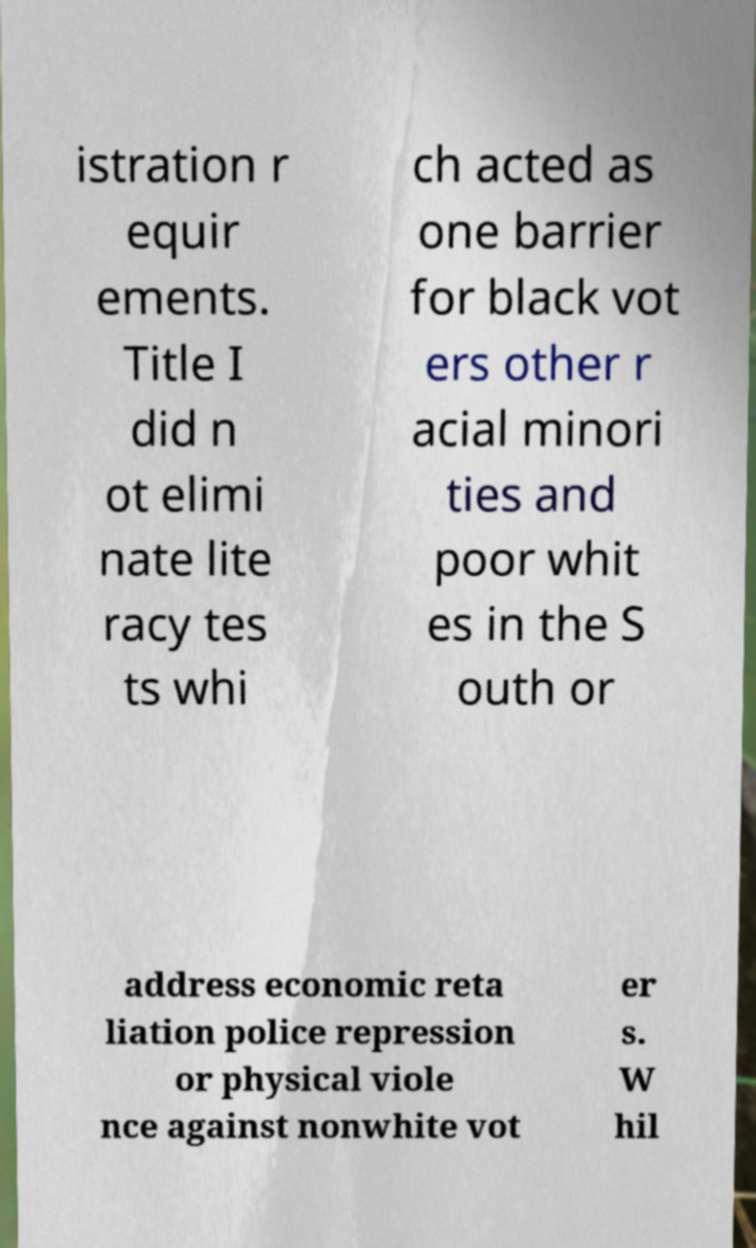I need the written content from this picture converted into text. Can you do that? istration r equir ements. Title I did n ot elimi nate lite racy tes ts whi ch acted as one barrier for black vot ers other r acial minori ties and poor whit es in the S outh or address economic reta liation police repression or physical viole nce against nonwhite vot er s. W hil 